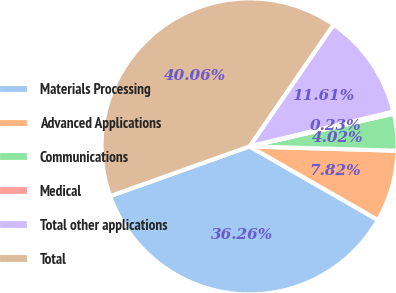Convert chart. <chart><loc_0><loc_0><loc_500><loc_500><pie_chart><fcel>Materials Processing<fcel>Advanced Applications<fcel>Communications<fcel>Medical<fcel>Total other applications<fcel>Total<nl><fcel>36.26%<fcel>7.82%<fcel>4.02%<fcel>0.23%<fcel>11.61%<fcel>40.06%<nl></chart> 